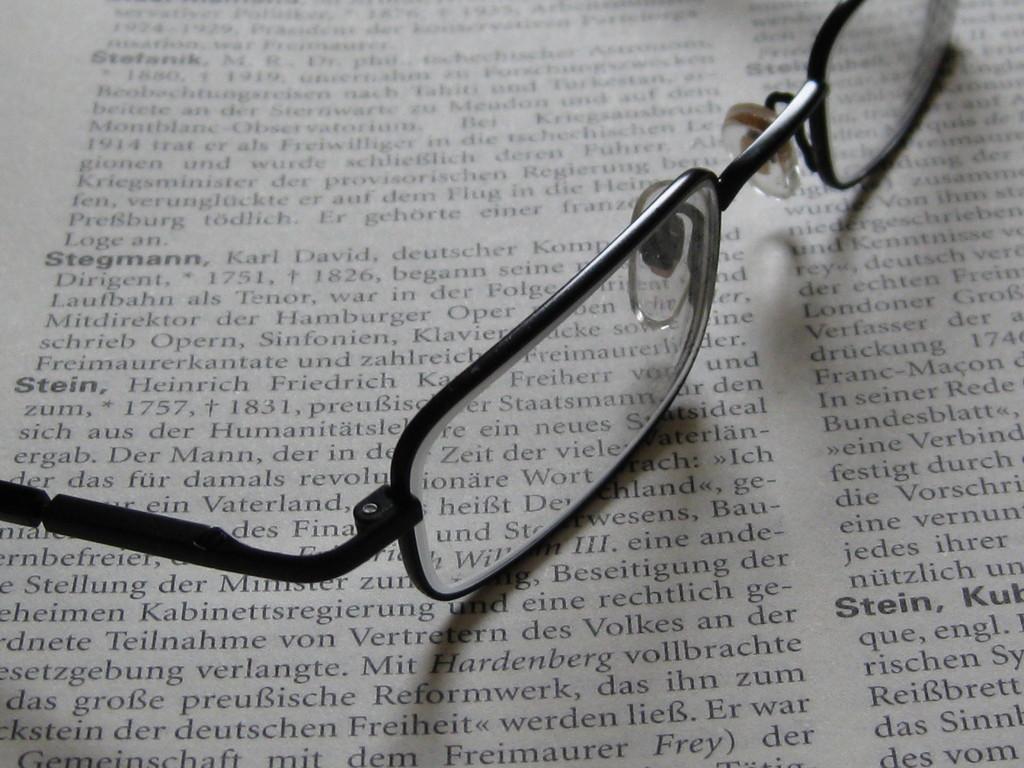Describe this image in one or two sentences. In this picture we can see the spectacles on the paper and on the paper it is written something. 